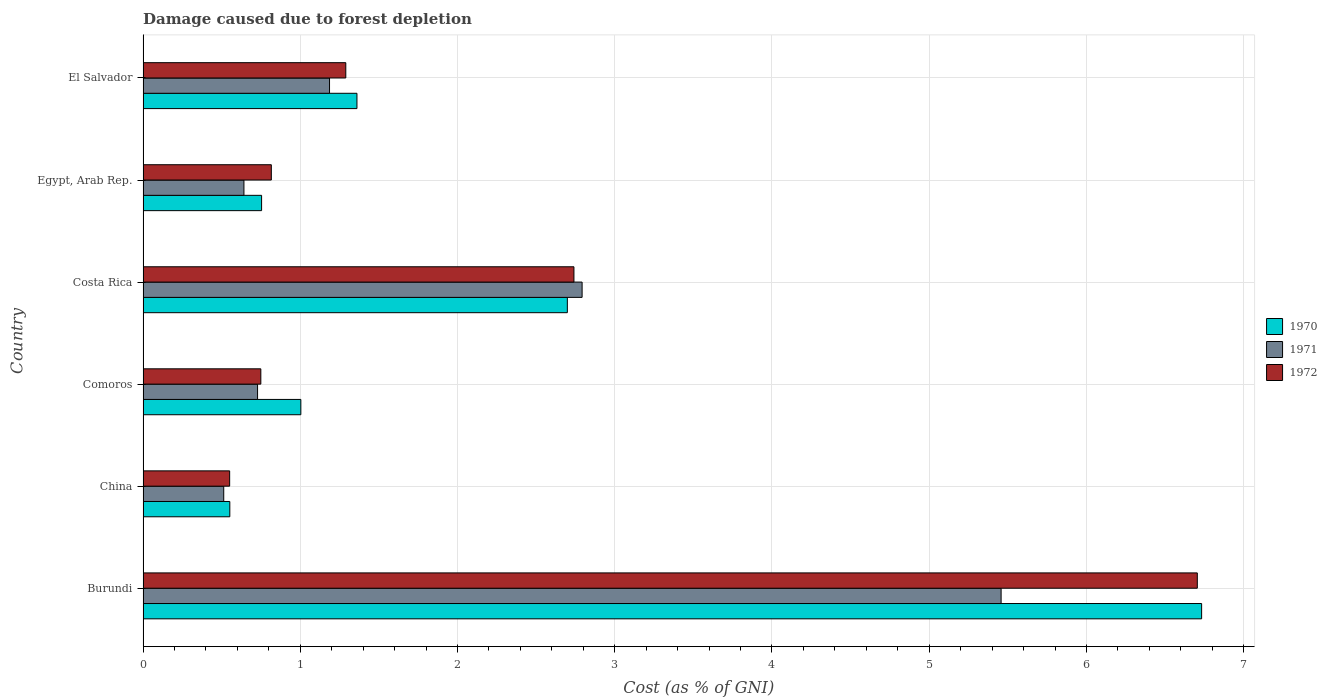How many different coloured bars are there?
Your answer should be very brief. 3. How many groups of bars are there?
Provide a succinct answer. 6. Are the number of bars per tick equal to the number of legend labels?
Offer a terse response. Yes. How many bars are there on the 5th tick from the bottom?
Offer a terse response. 3. What is the label of the 1st group of bars from the top?
Offer a very short reply. El Salvador. In how many cases, is the number of bars for a given country not equal to the number of legend labels?
Offer a terse response. 0. What is the cost of damage caused due to forest depletion in 1972 in Burundi?
Make the answer very short. 6.71. Across all countries, what is the maximum cost of damage caused due to forest depletion in 1970?
Your answer should be very brief. 6.73. Across all countries, what is the minimum cost of damage caused due to forest depletion in 1972?
Provide a succinct answer. 0.55. In which country was the cost of damage caused due to forest depletion in 1971 maximum?
Ensure brevity in your answer.  Burundi. In which country was the cost of damage caused due to forest depletion in 1970 minimum?
Offer a terse response. China. What is the total cost of damage caused due to forest depletion in 1971 in the graph?
Keep it short and to the point. 11.32. What is the difference between the cost of damage caused due to forest depletion in 1971 in Burundi and that in Comoros?
Make the answer very short. 4.73. What is the difference between the cost of damage caused due to forest depletion in 1970 in Comoros and the cost of damage caused due to forest depletion in 1971 in Egypt, Arab Rep.?
Your response must be concise. 0.36. What is the average cost of damage caused due to forest depletion in 1971 per country?
Ensure brevity in your answer.  1.89. What is the difference between the cost of damage caused due to forest depletion in 1970 and cost of damage caused due to forest depletion in 1971 in Egypt, Arab Rep.?
Ensure brevity in your answer.  0.11. In how many countries, is the cost of damage caused due to forest depletion in 1972 greater than 0.2 %?
Make the answer very short. 6. What is the ratio of the cost of damage caused due to forest depletion in 1972 in Costa Rica to that in Egypt, Arab Rep.?
Provide a succinct answer. 3.36. Is the difference between the cost of damage caused due to forest depletion in 1970 in Burundi and El Salvador greater than the difference between the cost of damage caused due to forest depletion in 1971 in Burundi and El Salvador?
Offer a very short reply. Yes. What is the difference between the highest and the second highest cost of damage caused due to forest depletion in 1972?
Give a very brief answer. 3.96. What is the difference between the highest and the lowest cost of damage caused due to forest depletion in 1970?
Provide a succinct answer. 6.18. Is the sum of the cost of damage caused due to forest depletion in 1971 in Burundi and Egypt, Arab Rep. greater than the maximum cost of damage caused due to forest depletion in 1972 across all countries?
Keep it short and to the point. No. How many bars are there?
Offer a very short reply. 18. What is the difference between two consecutive major ticks on the X-axis?
Keep it short and to the point. 1. Does the graph contain any zero values?
Offer a terse response. No. Where does the legend appear in the graph?
Provide a short and direct response. Center right. How are the legend labels stacked?
Give a very brief answer. Vertical. What is the title of the graph?
Your answer should be compact. Damage caused due to forest depletion. Does "2009" appear as one of the legend labels in the graph?
Provide a succinct answer. No. What is the label or title of the X-axis?
Offer a terse response. Cost (as % of GNI). What is the label or title of the Y-axis?
Ensure brevity in your answer.  Country. What is the Cost (as % of GNI) of 1970 in Burundi?
Make the answer very short. 6.73. What is the Cost (as % of GNI) of 1971 in Burundi?
Ensure brevity in your answer.  5.46. What is the Cost (as % of GNI) in 1972 in Burundi?
Keep it short and to the point. 6.71. What is the Cost (as % of GNI) of 1970 in China?
Provide a succinct answer. 0.55. What is the Cost (as % of GNI) in 1971 in China?
Keep it short and to the point. 0.51. What is the Cost (as % of GNI) of 1972 in China?
Your response must be concise. 0.55. What is the Cost (as % of GNI) of 1970 in Comoros?
Offer a very short reply. 1. What is the Cost (as % of GNI) in 1971 in Comoros?
Your response must be concise. 0.73. What is the Cost (as % of GNI) of 1972 in Comoros?
Offer a very short reply. 0.75. What is the Cost (as % of GNI) of 1970 in Costa Rica?
Offer a terse response. 2.7. What is the Cost (as % of GNI) of 1971 in Costa Rica?
Provide a succinct answer. 2.79. What is the Cost (as % of GNI) of 1972 in Costa Rica?
Provide a succinct answer. 2.74. What is the Cost (as % of GNI) of 1970 in Egypt, Arab Rep.?
Your response must be concise. 0.75. What is the Cost (as % of GNI) of 1971 in Egypt, Arab Rep.?
Provide a succinct answer. 0.64. What is the Cost (as % of GNI) in 1972 in Egypt, Arab Rep.?
Keep it short and to the point. 0.82. What is the Cost (as % of GNI) in 1970 in El Salvador?
Ensure brevity in your answer.  1.36. What is the Cost (as % of GNI) in 1971 in El Salvador?
Keep it short and to the point. 1.19. What is the Cost (as % of GNI) in 1972 in El Salvador?
Your response must be concise. 1.29. Across all countries, what is the maximum Cost (as % of GNI) in 1970?
Provide a succinct answer. 6.73. Across all countries, what is the maximum Cost (as % of GNI) of 1971?
Offer a terse response. 5.46. Across all countries, what is the maximum Cost (as % of GNI) in 1972?
Provide a succinct answer. 6.71. Across all countries, what is the minimum Cost (as % of GNI) in 1970?
Your response must be concise. 0.55. Across all countries, what is the minimum Cost (as % of GNI) in 1971?
Offer a very short reply. 0.51. Across all countries, what is the minimum Cost (as % of GNI) of 1972?
Keep it short and to the point. 0.55. What is the total Cost (as % of GNI) in 1970 in the graph?
Offer a terse response. 13.1. What is the total Cost (as % of GNI) of 1971 in the graph?
Your response must be concise. 11.32. What is the total Cost (as % of GNI) in 1972 in the graph?
Provide a succinct answer. 12.85. What is the difference between the Cost (as % of GNI) of 1970 in Burundi and that in China?
Offer a very short reply. 6.18. What is the difference between the Cost (as % of GNI) in 1971 in Burundi and that in China?
Give a very brief answer. 4.94. What is the difference between the Cost (as % of GNI) of 1972 in Burundi and that in China?
Your response must be concise. 6.15. What is the difference between the Cost (as % of GNI) in 1970 in Burundi and that in Comoros?
Ensure brevity in your answer.  5.73. What is the difference between the Cost (as % of GNI) of 1971 in Burundi and that in Comoros?
Provide a short and direct response. 4.73. What is the difference between the Cost (as % of GNI) of 1972 in Burundi and that in Comoros?
Offer a terse response. 5.96. What is the difference between the Cost (as % of GNI) in 1970 in Burundi and that in Costa Rica?
Keep it short and to the point. 4.03. What is the difference between the Cost (as % of GNI) of 1971 in Burundi and that in Costa Rica?
Offer a terse response. 2.66. What is the difference between the Cost (as % of GNI) of 1972 in Burundi and that in Costa Rica?
Provide a succinct answer. 3.96. What is the difference between the Cost (as % of GNI) of 1970 in Burundi and that in Egypt, Arab Rep.?
Provide a short and direct response. 5.98. What is the difference between the Cost (as % of GNI) in 1971 in Burundi and that in Egypt, Arab Rep.?
Offer a very short reply. 4.82. What is the difference between the Cost (as % of GNI) of 1972 in Burundi and that in Egypt, Arab Rep.?
Keep it short and to the point. 5.89. What is the difference between the Cost (as % of GNI) of 1970 in Burundi and that in El Salvador?
Your answer should be very brief. 5.37. What is the difference between the Cost (as % of GNI) of 1971 in Burundi and that in El Salvador?
Make the answer very short. 4.27. What is the difference between the Cost (as % of GNI) in 1972 in Burundi and that in El Salvador?
Your response must be concise. 5.42. What is the difference between the Cost (as % of GNI) in 1970 in China and that in Comoros?
Give a very brief answer. -0.45. What is the difference between the Cost (as % of GNI) in 1971 in China and that in Comoros?
Ensure brevity in your answer.  -0.22. What is the difference between the Cost (as % of GNI) in 1972 in China and that in Comoros?
Your answer should be compact. -0.2. What is the difference between the Cost (as % of GNI) in 1970 in China and that in Costa Rica?
Your answer should be very brief. -2.15. What is the difference between the Cost (as % of GNI) in 1971 in China and that in Costa Rica?
Provide a succinct answer. -2.28. What is the difference between the Cost (as % of GNI) of 1972 in China and that in Costa Rica?
Your answer should be compact. -2.19. What is the difference between the Cost (as % of GNI) in 1970 in China and that in Egypt, Arab Rep.?
Provide a succinct answer. -0.2. What is the difference between the Cost (as % of GNI) in 1971 in China and that in Egypt, Arab Rep.?
Provide a short and direct response. -0.13. What is the difference between the Cost (as % of GNI) in 1972 in China and that in Egypt, Arab Rep.?
Your answer should be compact. -0.27. What is the difference between the Cost (as % of GNI) in 1970 in China and that in El Salvador?
Your response must be concise. -0.81. What is the difference between the Cost (as % of GNI) in 1971 in China and that in El Salvador?
Give a very brief answer. -0.67. What is the difference between the Cost (as % of GNI) in 1972 in China and that in El Salvador?
Your answer should be very brief. -0.74. What is the difference between the Cost (as % of GNI) in 1970 in Comoros and that in Costa Rica?
Ensure brevity in your answer.  -1.7. What is the difference between the Cost (as % of GNI) in 1971 in Comoros and that in Costa Rica?
Give a very brief answer. -2.06. What is the difference between the Cost (as % of GNI) in 1972 in Comoros and that in Costa Rica?
Provide a succinct answer. -1.99. What is the difference between the Cost (as % of GNI) in 1970 in Comoros and that in Egypt, Arab Rep.?
Give a very brief answer. 0.25. What is the difference between the Cost (as % of GNI) in 1971 in Comoros and that in Egypt, Arab Rep.?
Make the answer very short. 0.09. What is the difference between the Cost (as % of GNI) of 1972 in Comoros and that in Egypt, Arab Rep.?
Your answer should be compact. -0.07. What is the difference between the Cost (as % of GNI) in 1970 in Comoros and that in El Salvador?
Your answer should be compact. -0.36. What is the difference between the Cost (as % of GNI) of 1971 in Comoros and that in El Salvador?
Your response must be concise. -0.46. What is the difference between the Cost (as % of GNI) of 1972 in Comoros and that in El Salvador?
Offer a terse response. -0.54. What is the difference between the Cost (as % of GNI) of 1970 in Costa Rica and that in Egypt, Arab Rep.?
Give a very brief answer. 1.94. What is the difference between the Cost (as % of GNI) in 1971 in Costa Rica and that in Egypt, Arab Rep.?
Your response must be concise. 2.15. What is the difference between the Cost (as % of GNI) in 1972 in Costa Rica and that in Egypt, Arab Rep.?
Your answer should be compact. 1.92. What is the difference between the Cost (as % of GNI) in 1970 in Costa Rica and that in El Salvador?
Offer a terse response. 1.34. What is the difference between the Cost (as % of GNI) in 1971 in Costa Rica and that in El Salvador?
Your answer should be very brief. 1.61. What is the difference between the Cost (as % of GNI) in 1972 in Costa Rica and that in El Salvador?
Your answer should be compact. 1.45. What is the difference between the Cost (as % of GNI) of 1970 in Egypt, Arab Rep. and that in El Salvador?
Offer a terse response. -0.61. What is the difference between the Cost (as % of GNI) of 1971 in Egypt, Arab Rep. and that in El Salvador?
Provide a short and direct response. -0.54. What is the difference between the Cost (as % of GNI) of 1972 in Egypt, Arab Rep. and that in El Salvador?
Your answer should be compact. -0.47. What is the difference between the Cost (as % of GNI) in 1970 in Burundi and the Cost (as % of GNI) in 1971 in China?
Offer a very short reply. 6.22. What is the difference between the Cost (as % of GNI) of 1970 in Burundi and the Cost (as % of GNI) of 1972 in China?
Offer a terse response. 6.18. What is the difference between the Cost (as % of GNI) in 1971 in Burundi and the Cost (as % of GNI) in 1972 in China?
Offer a very short reply. 4.91. What is the difference between the Cost (as % of GNI) in 1970 in Burundi and the Cost (as % of GNI) in 1971 in Comoros?
Your answer should be compact. 6. What is the difference between the Cost (as % of GNI) in 1970 in Burundi and the Cost (as % of GNI) in 1972 in Comoros?
Keep it short and to the point. 5.98. What is the difference between the Cost (as % of GNI) of 1971 in Burundi and the Cost (as % of GNI) of 1972 in Comoros?
Ensure brevity in your answer.  4.71. What is the difference between the Cost (as % of GNI) of 1970 in Burundi and the Cost (as % of GNI) of 1971 in Costa Rica?
Your answer should be compact. 3.94. What is the difference between the Cost (as % of GNI) of 1970 in Burundi and the Cost (as % of GNI) of 1972 in Costa Rica?
Ensure brevity in your answer.  3.99. What is the difference between the Cost (as % of GNI) of 1971 in Burundi and the Cost (as % of GNI) of 1972 in Costa Rica?
Make the answer very short. 2.72. What is the difference between the Cost (as % of GNI) in 1970 in Burundi and the Cost (as % of GNI) in 1971 in Egypt, Arab Rep.?
Make the answer very short. 6.09. What is the difference between the Cost (as % of GNI) of 1970 in Burundi and the Cost (as % of GNI) of 1972 in Egypt, Arab Rep.?
Your answer should be compact. 5.92. What is the difference between the Cost (as % of GNI) of 1971 in Burundi and the Cost (as % of GNI) of 1972 in Egypt, Arab Rep.?
Provide a succinct answer. 4.64. What is the difference between the Cost (as % of GNI) in 1970 in Burundi and the Cost (as % of GNI) in 1971 in El Salvador?
Offer a very short reply. 5.55. What is the difference between the Cost (as % of GNI) in 1970 in Burundi and the Cost (as % of GNI) in 1972 in El Salvador?
Your answer should be compact. 5.44. What is the difference between the Cost (as % of GNI) in 1971 in Burundi and the Cost (as % of GNI) in 1972 in El Salvador?
Keep it short and to the point. 4.17. What is the difference between the Cost (as % of GNI) in 1970 in China and the Cost (as % of GNI) in 1971 in Comoros?
Make the answer very short. -0.18. What is the difference between the Cost (as % of GNI) of 1970 in China and the Cost (as % of GNI) of 1972 in Comoros?
Offer a terse response. -0.2. What is the difference between the Cost (as % of GNI) of 1971 in China and the Cost (as % of GNI) of 1972 in Comoros?
Give a very brief answer. -0.24. What is the difference between the Cost (as % of GNI) in 1970 in China and the Cost (as % of GNI) in 1971 in Costa Rica?
Provide a succinct answer. -2.24. What is the difference between the Cost (as % of GNI) in 1970 in China and the Cost (as % of GNI) in 1972 in Costa Rica?
Your answer should be very brief. -2.19. What is the difference between the Cost (as % of GNI) in 1971 in China and the Cost (as % of GNI) in 1972 in Costa Rica?
Your response must be concise. -2.23. What is the difference between the Cost (as % of GNI) in 1970 in China and the Cost (as % of GNI) in 1971 in Egypt, Arab Rep.?
Offer a terse response. -0.09. What is the difference between the Cost (as % of GNI) of 1970 in China and the Cost (as % of GNI) of 1972 in Egypt, Arab Rep.?
Make the answer very short. -0.26. What is the difference between the Cost (as % of GNI) in 1971 in China and the Cost (as % of GNI) in 1972 in Egypt, Arab Rep.?
Offer a very short reply. -0.3. What is the difference between the Cost (as % of GNI) in 1970 in China and the Cost (as % of GNI) in 1971 in El Salvador?
Your response must be concise. -0.63. What is the difference between the Cost (as % of GNI) of 1970 in China and the Cost (as % of GNI) of 1972 in El Salvador?
Give a very brief answer. -0.74. What is the difference between the Cost (as % of GNI) in 1971 in China and the Cost (as % of GNI) in 1972 in El Salvador?
Provide a succinct answer. -0.78. What is the difference between the Cost (as % of GNI) in 1970 in Comoros and the Cost (as % of GNI) in 1971 in Costa Rica?
Offer a terse response. -1.79. What is the difference between the Cost (as % of GNI) in 1970 in Comoros and the Cost (as % of GNI) in 1972 in Costa Rica?
Provide a short and direct response. -1.74. What is the difference between the Cost (as % of GNI) of 1971 in Comoros and the Cost (as % of GNI) of 1972 in Costa Rica?
Make the answer very short. -2.01. What is the difference between the Cost (as % of GNI) of 1970 in Comoros and the Cost (as % of GNI) of 1971 in Egypt, Arab Rep.?
Offer a very short reply. 0.36. What is the difference between the Cost (as % of GNI) of 1970 in Comoros and the Cost (as % of GNI) of 1972 in Egypt, Arab Rep.?
Give a very brief answer. 0.19. What is the difference between the Cost (as % of GNI) in 1971 in Comoros and the Cost (as % of GNI) in 1972 in Egypt, Arab Rep.?
Provide a short and direct response. -0.09. What is the difference between the Cost (as % of GNI) in 1970 in Comoros and the Cost (as % of GNI) in 1971 in El Salvador?
Your answer should be very brief. -0.18. What is the difference between the Cost (as % of GNI) in 1970 in Comoros and the Cost (as % of GNI) in 1972 in El Salvador?
Keep it short and to the point. -0.29. What is the difference between the Cost (as % of GNI) in 1971 in Comoros and the Cost (as % of GNI) in 1972 in El Salvador?
Make the answer very short. -0.56. What is the difference between the Cost (as % of GNI) in 1970 in Costa Rica and the Cost (as % of GNI) in 1971 in Egypt, Arab Rep.?
Give a very brief answer. 2.06. What is the difference between the Cost (as % of GNI) in 1970 in Costa Rica and the Cost (as % of GNI) in 1972 in Egypt, Arab Rep.?
Keep it short and to the point. 1.88. What is the difference between the Cost (as % of GNI) of 1971 in Costa Rica and the Cost (as % of GNI) of 1972 in Egypt, Arab Rep.?
Your answer should be very brief. 1.98. What is the difference between the Cost (as % of GNI) in 1970 in Costa Rica and the Cost (as % of GNI) in 1971 in El Salvador?
Keep it short and to the point. 1.51. What is the difference between the Cost (as % of GNI) of 1970 in Costa Rica and the Cost (as % of GNI) of 1972 in El Salvador?
Offer a terse response. 1.41. What is the difference between the Cost (as % of GNI) of 1971 in Costa Rica and the Cost (as % of GNI) of 1972 in El Salvador?
Offer a terse response. 1.5. What is the difference between the Cost (as % of GNI) in 1970 in Egypt, Arab Rep. and the Cost (as % of GNI) in 1971 in El Salvador?
Ensure brevity in your answer.  -0.43. What is the difference between the Cost (as % of GNI) in 1970 in Egypt, Arab Rep. and the Cost (as % of GNI) in 1972 in El Salvador?
Your answer should be compact. -0.54. What is the difference between the Cost (as % of GNI) of 1971 in Egypt, Arab Rep. and the Cost (as % of GNI) of 1972 in El Salvador?
Provide a short and direct response. -0.65. What is the average Cost (as % of GNI) in 1970 per country?
Make the answer very short. 2.18. What is the average Cost (as % of GNI) in 1971 per country?
Ensure brevity in your answer.  1.89. What is the average Cost (as % of GNI) of 1972 per country?
Make the answer very short. 2.14. What is the difference between the Cost (as % of GNI) in 1970 and Cost (as % of GNI) in 1971 in Burundi?
Ensure brevity in your answer.  1.28. What is the difference between the Cost (as % of GNI) of 1970 and Cost (as % of GNI) of 1972 in Burundi?
Provide a succinct answer. 0.03. What is the difference between the Cost (as % of GNI) in 1971 and Cost (as % of GNI) in 1972 in Burundi?
Keep it short and to the point. -1.25. What is the difference between the Cost (as % of GNI) in 1970 and Cost (as % of GNI) in 1971 in China?
Provide a succinct answer. 0.04. What is the difference between the Cost (as % of GNI) in 1971 and Cost (as % of GNI) in 1972 in China?
Provide a short and direct response. -0.04. What is the difference between the Cost (as % of GNI) of 1970 and Cost (as % of GNI) of 1971 in Comoros?
Your answer should be compact. 0.28. What is the difference between the Cost (as % of GNI) in 1970 and Cost (as % of GNI) in 1972 in Comoros?
Your response must be concise. 0.25. What is the difference between the Cost (as % of GNI) of 1971 and Cost (as % of GNI) of 1972 in Comoros?
Make the answer very short. -0.02. What is the difference between the Cost (as % of GNI) of 1970 and Cost (as % of GNI) of 1971 in Costa Rica?
Make the answer very short. -0.09. What is the difference between the Cost (as % of GNI) in 1970 and Cost (as % of GNI) in 1972 in Costa Rica?
Offer a very short reply. -0.04. What is the difference between the Cost (as % of GNI) of 1971 and Cost (as % of GNI) of 1972 in Costa Rica?
Your answer should be very brief. 0.05. What is the difference between the Cost (as % of GNI) in 1970 and Cost (as % of GNI) in 1971 in Egypt, Arab Rep.?
Offer a terse response. 0.11. What is the difference between the Cost (as % of GNI) of 1970 and Cost (as % of GNI) of 1972 in Egypt, Arab Rep.?
Ensure brevity in your answer.  -0.06. What is the difference between the Cost (as % of GNI) of 1971 and Cost (as % of GNI) of 1972 in Egypt, Arab Rep.?
Offer a very short reply. -0.17. What is the difference between the Cost (as % of GNI) of 1970 and Cost (as % of GNI) of 1971 in El Salvador?
Provide a succinct answer. 0.17. What is the difference between the Cost (as % of GNI) of 1970 and Cost (as % of GNI) of 1972 in El Salvador?
Provide a short and direct response. 0.07. What is the difference between the Cost (as % of GNI) of 1971 and Cost (as % of GNI) of 1972 in El Salvador?
Offer a very short reply. -0.1. What is the ratio of the Cost (as % of GNI) of 1970 in Burundi to that in China?
Give a very brief answer. 12.2. What is the ratio of the Cost (as % of GNI) of 1971 in Burundi to that in China?
Your answer should be compact. 10.64. What is the ratio of the Cost (as % of GNI) in 1972 in Burundi to that in China?
Offer a very short reply. 12.17. What is the ratio of the Cost (as % of GNI) of 1970 in Burundi to that in Comoros?
Your response must be concise. 6.71. What is the ratio of the Cost (as % of GNI) of 1971 in Burundi to that in Comoros?
Your answer should be compact. 7.49. What is the ratio of the Cost (as % of GNI) in 1972 in Burundi to that in Comoros?
Ensure brevity in your answer.  8.95. What is the ratio of the Cost (as % of GNI) in 1970 in Burundi to that in Costa Rica?
Ensure brevity in your answer.  2.49. What is the ratio of the Cost (as % of GNI) in 1971 in Burundi to that in Costa Rica?
Give a very brief answer. 1.95. What is the ratio of the Cost (as % of GNI) of 1972 in Burundi to that in Costa Rica?
Make the answer very short. 2.45. What is the ratio of the Cost (as % of GNI) in 1970 in Burundi to that in Egypt, Arab Rep.?
Ensure brevity in your answer.  8.93. What is the ratio of the Cost (as % of GNI) in 1971 in Burundi to that in Egypt, Arab Rep.?
Provide a succinct answer. 8.51. What is the ratio of the Cost (as % of GNI) of 1972 in Burundi to that in Egypt, Arab Rep.?
Your answer should be very brief. 8.22. What is the ratio of the Cost (as % of GNI) in 1970 in Burundi to that in El Salvador?
Your answer should be very brief. 4.95. What is the ratio of the Cost (as % of GNI) of 1971 in Burundi to that in El Salvador?
Ensure brevity in your answer.  4.6. What is the ratio of the Cost (as % of GNI) in 1970 in China to that in Comoros?
Give a very brief answer. 0.55. What is the ratio of the Cost (as % of GNI) of 1971 in China to that in Comoros?
Provide a short and direct response. 0.7. What is the ratio of the Cost (as % of GNI) of 1972 in China to that in Comoros?
Keep it short and to the point. 0.74. What is the ratio of the Cost (as % of GNI) in 1970 in China to that in Costa Rica?
Make the answer very short. 0.2. What is the ratio of the Cost (as % of GNI) of 1971 in China to that in Costa Rica?
Your response must be concise. 0.18. What is the ratio of the Cost (as % of GNI) in 1972 in China to that in Costa Rica?
Your response must be concise. 0.2. What is the ratio of the Cost (as % of GNI) in 1970 in China to that in Egypt, Arab Rep.?
Offer a very short reply. 0.73. What is the ratio of the Cost (as % of GNI) of 1971 in China to that in Egypt, Arab Rep.?
Keep it short and to the point. 0.8. What is the ratio of the Cost (as % of GNI) of 1972 in China to that in Egypt, Arab Rep.?
Ensure brevity in your answer.  0.68. What is the ratio of the Cost (as % of GNI) in 1970 in China to that in El Salvador?
Make the answer very short. 0.41. What is the ratio of the Cost (as % of GNI) in 1971 in China to that in El Salvador?
Ensure brevity in your answer.  0.43. What is the ratio of the Cost (as % of GNI) of 1972 in China to that in El Salvador?
Your response must be concise. 0.43. What is the ratio of the Cost (as % of GNI) in 1970 in Comoros to that in Costa Rica?
Provide a short and direct response. 0.37. What is the ratio of the Cost (as % of GNI) in 1971 in Comoros to that in Costa Rica?
Your response must be concise. 0.26. What is the ratio of the Cost (as % of GNI) of 1972 in Comoros to that in Costa Rica?
Keep it short and to the point. 0.27. What is the ratio of the Cost (as % of GNI) of 1970 in Comoros to that in Egypt, Arab Rep.?
Your response must be concise. 1.33. What is the ratio of the Cost (as % of GNI) of 1971 in Comoros to that in Egypt, Arab Rep.?
Your response must be concise. 1.14. What is the ratio of the Cost (as % of GNI) in 1972 in Comoros to that in Egypt, Arab Rep.?
Your response must be concise. 0.92. What is the ratio of the Cost (as % of GNI) in 1970 in Comoros to that in El Salvador?
Offer a very short reply. 0.74. What is the ratio of the Cost (as % of GNI) of 1971 in Comoros to that in El Salvador?
Offer a terse response. 0.61. What is the ratio of the Cost (as % of GNI) of 1972 in Comoros to that in El Salvador?
Your answer should be compact. 0.58. What is the ratio of the Cost (as % of GNI) in 1970 in Costa Rica to that in Egypt, Arab Rep.?
Offer a very short reply. 3.58. What is the ratio of the Cost (as % of GNI) of 1971 in Costa Rica to that in Egypt, Arab Rep.?
Offer a very short reply. 4.35. What is the ratio of the Cost (as % of GNI) of 1972 in Costa Rica to that in Egypt, Arab Rep.?
Provide a succinct answer. 3.36. What is the ratio of the Cost (as % of GNI) in 1970 in Costa Rica to that in El Salvador?
Offer a terse response. 1.98. What is the ratio of the Cost (as % of GNI) in 1971 in Costa Rica to that in El Salvador?
Ensure brevity in your answer.  2.35. What is the ratio of the Cost (as % of GNI) of 1972 in Costa Rica to that in El Salvador?
Make the answer very short. 2.13. What is the ratio of the Cost (as % of GNI) of 1970 in Egypt, Arab Rep. to that in El Salvador?
Your answer should be compact. 0.55. What is the ratio of the Cost (as % of GNI) in 1971 in Egypt, Arab Rep. to that in El Salvador?
Make the answer very short. 0.54. What is the ratio of the Cost (as % of GNI) of 1972 in Egypt, Arab Rep. to that in El Salvador?
Provide a succinct answer. 0.63. What is the difference between the highest and the second highest Cost (as % of GNI) in 1970?
Make the answer very short. 4.03. What is the difference between the highest and the second highest Cost (as % of GNI) of 1971?
Give a very brief answer. 2.66. What is the difference between the highest and the second highest Cost (as % of GNI) of 1972?
Offer a very short reply. 3.96. What is the difference between the highest and the lowest Cost (as % of GNI) of 1970?
Your response must be concise. 6.18. What is the difference between the highest and the lowest Cost (as % of GNI) in 1971?
Give a very brief answer. 4.94. What is the difference between the highest and the lowest Cost (as % of GNI) of 1972?
Offer a very short reply. 6.15. 